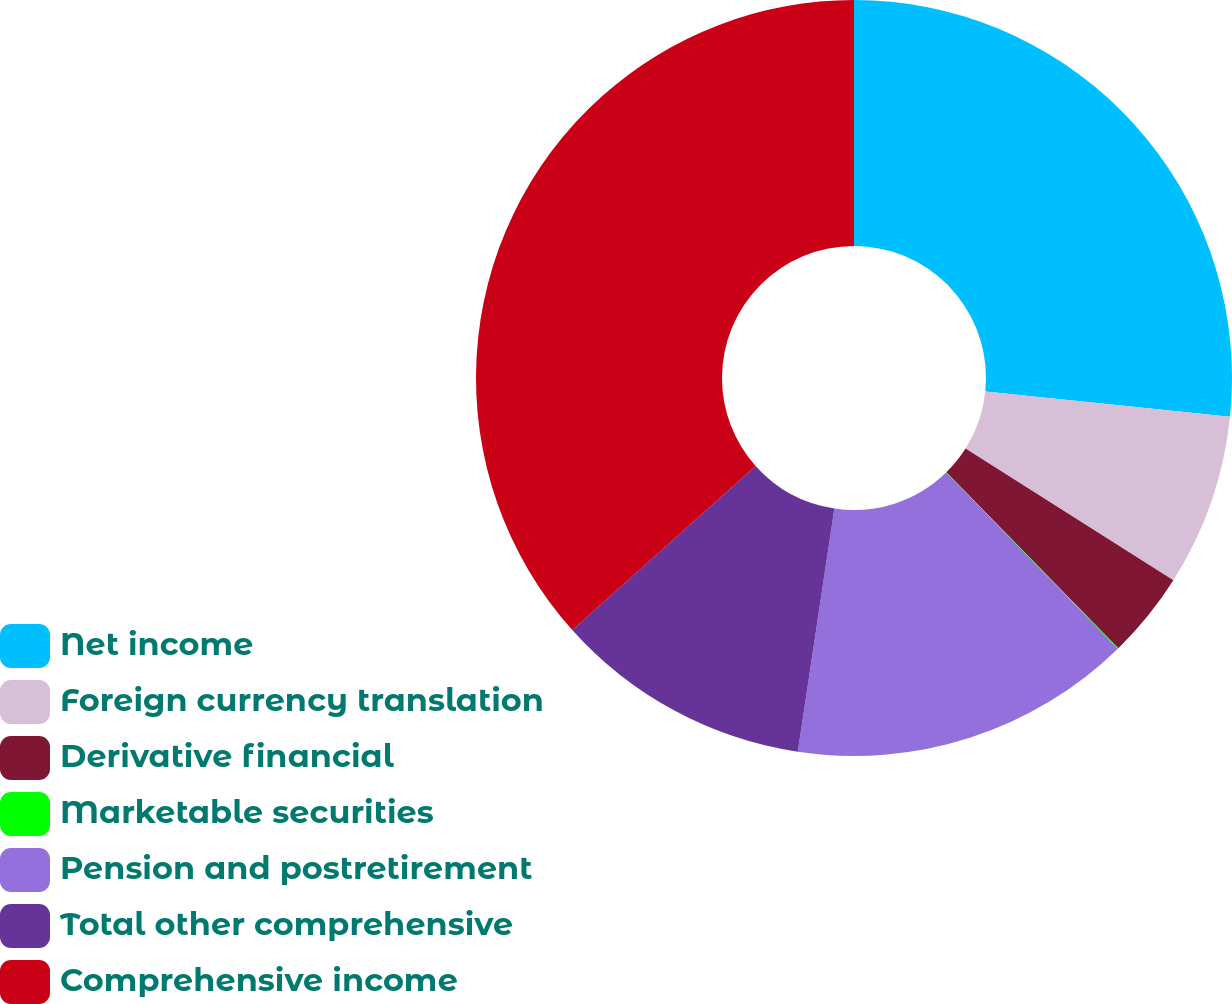<chart> <loc_0><loc_0><loc_500><loc_500><pie_chart><fcel>Net income<fcel>Foreign currency translation<fcel>Derivative financial<fcel>Marketable securities<fcel>Pension and postretirement<fcel>Total other comprehensive<fcel>Comprehensive income<nl><fcel>26.63%<fcel>7.35%<fcel>3.69%<fcel>0.03%<fcel>14.67%<fcel>11.01%<fcel>36.61%<nl></chart> 